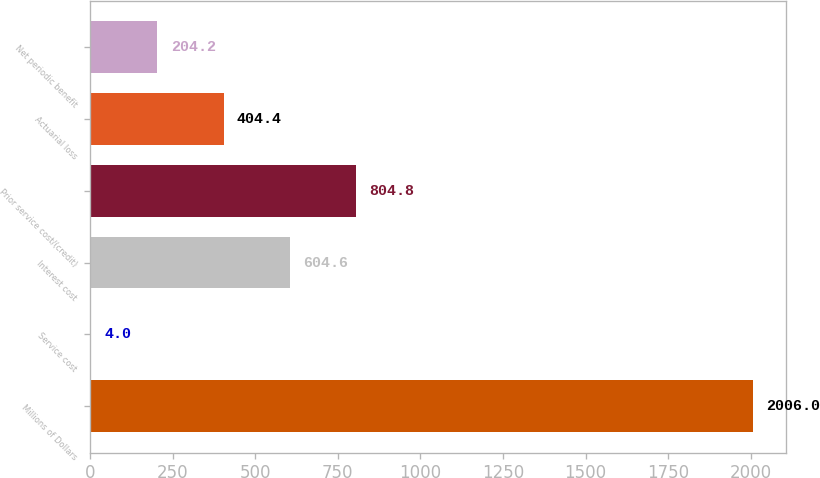Convert chart to OTSL. <chart><loc_0><loc_0><loc_500><loc_500><bar_chart><fcel>Millions of Dollars<fcel>Service cost<fcel>Interest cost<fcel>Prior service cost/(credit)<fcel>Actuarial loss<fcel>Net periodic benefit<nl><fcel>2006<fcel>4<fcel>604.6<fcel>804.8<fcel>404.4<fcel>204.2<nl></chart> 